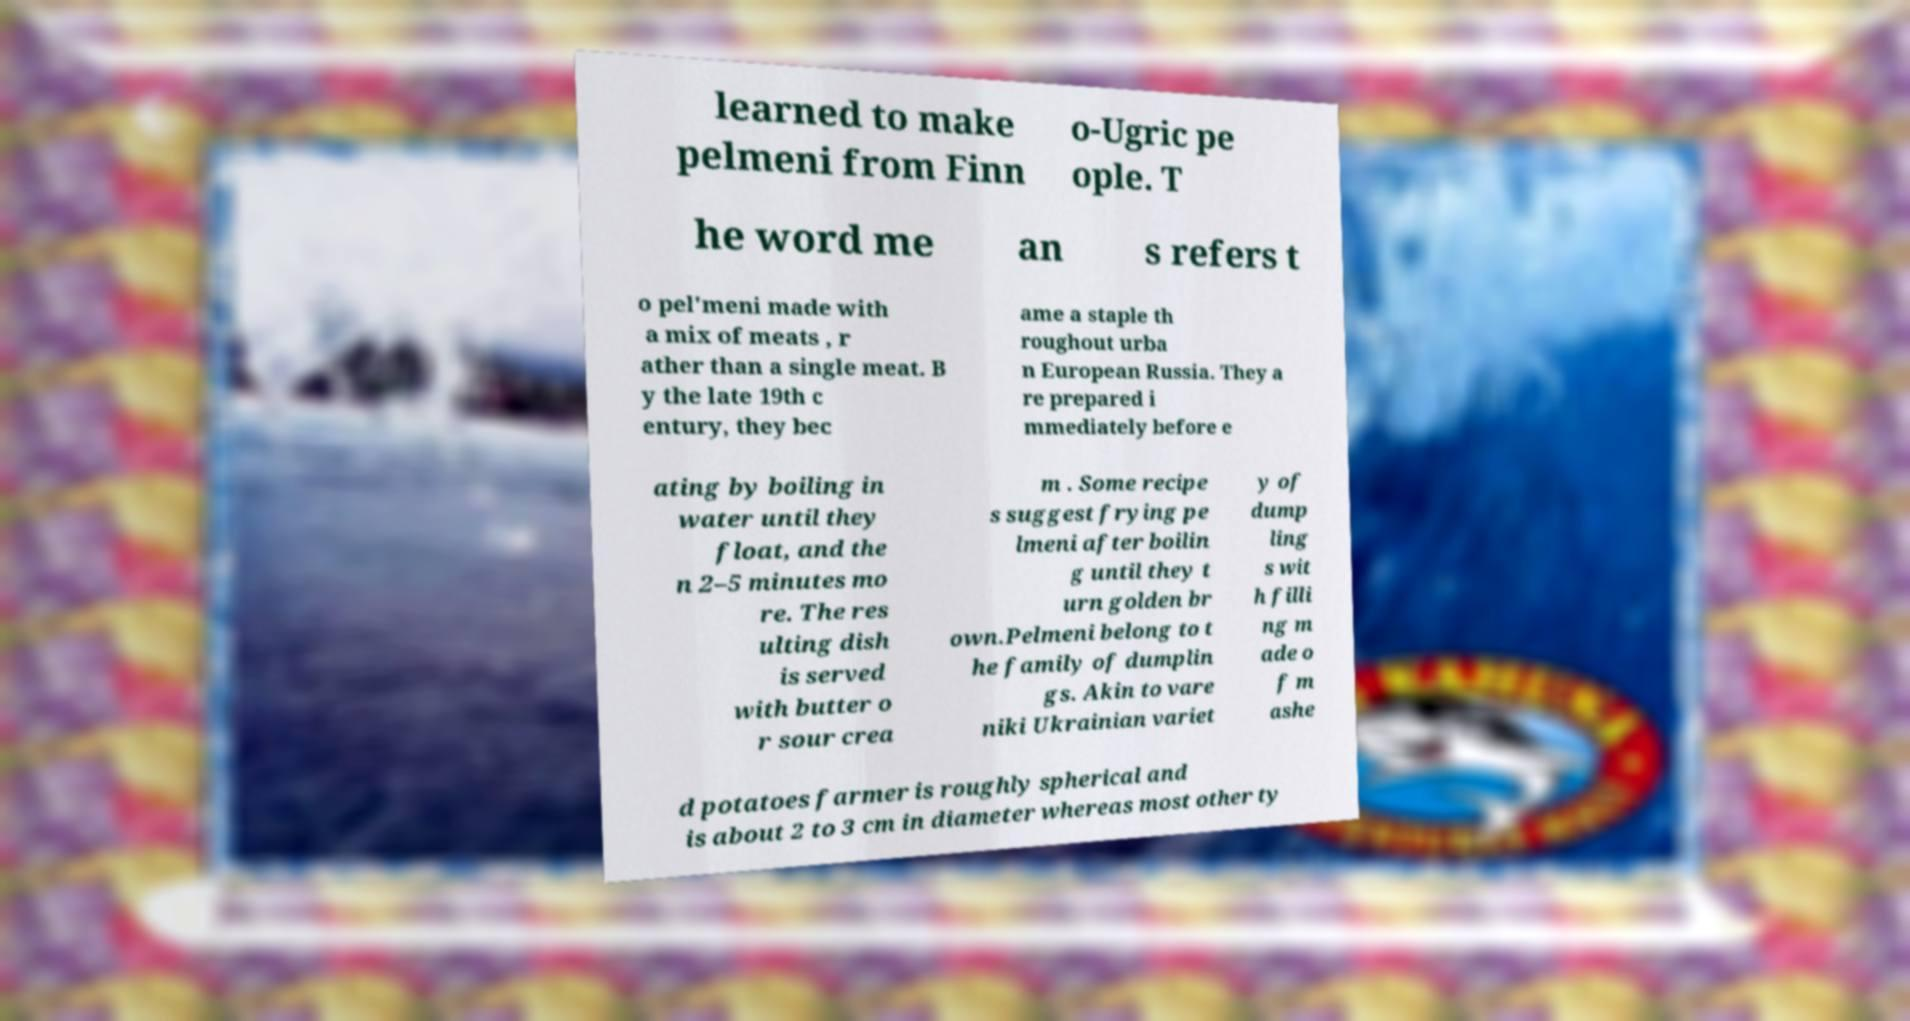There's text embedded in this image that I need extracted. Can you transcribe it verbatim? learned to make pelmeni from Finn o-Ugric pe ople. T he word me an s refers t o pel'meni made with a mix of meats , r ather than a single meat. B y the late 19th c entury, they bec ame a staple th roughout urba n European Russia. They a re prepared i mmediately before e ating by boiling in water until they float, and the n 2–5 minutes mo re. The res ulting dish is served with butter o r sour crea m . Some recipe s suggest frying pe lmeni after boilin g until they t urn golden br own.Pelmeni belong to t he family of dumplin gs. Akin to vare niki Ukrainian variet y of dump ling s wit h filli ng m ade o f m ashe d potatoes farmer is roughly spherical and is about 2 to 3 cm in diameter whereas most other ty 